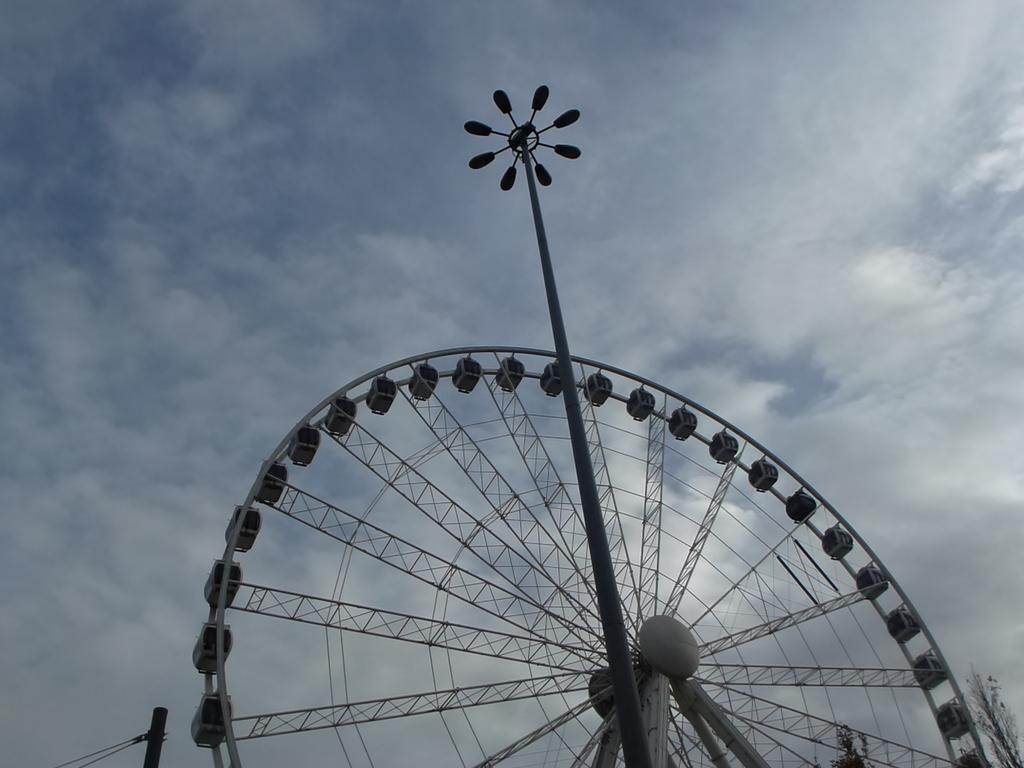What is the main structure in the image? There is a giant wheel in the image. What is located in front of the giant wheel? There is a pole with lights at the top in front of the giant wheel. What type of vegetation can be seen in the image? Trees are present in the image. What is attached to another pole in the image? Ropes are tied to another pole in the image. What is visible in the sky in the image? There are clouds in the sky in the image. What type of wool is being used to make the turkey's feathers in the image? There is no turkey or wool present in the image. How is the brother involved in the scene depicted in the image? There is no brother or any human figures present in the image. 